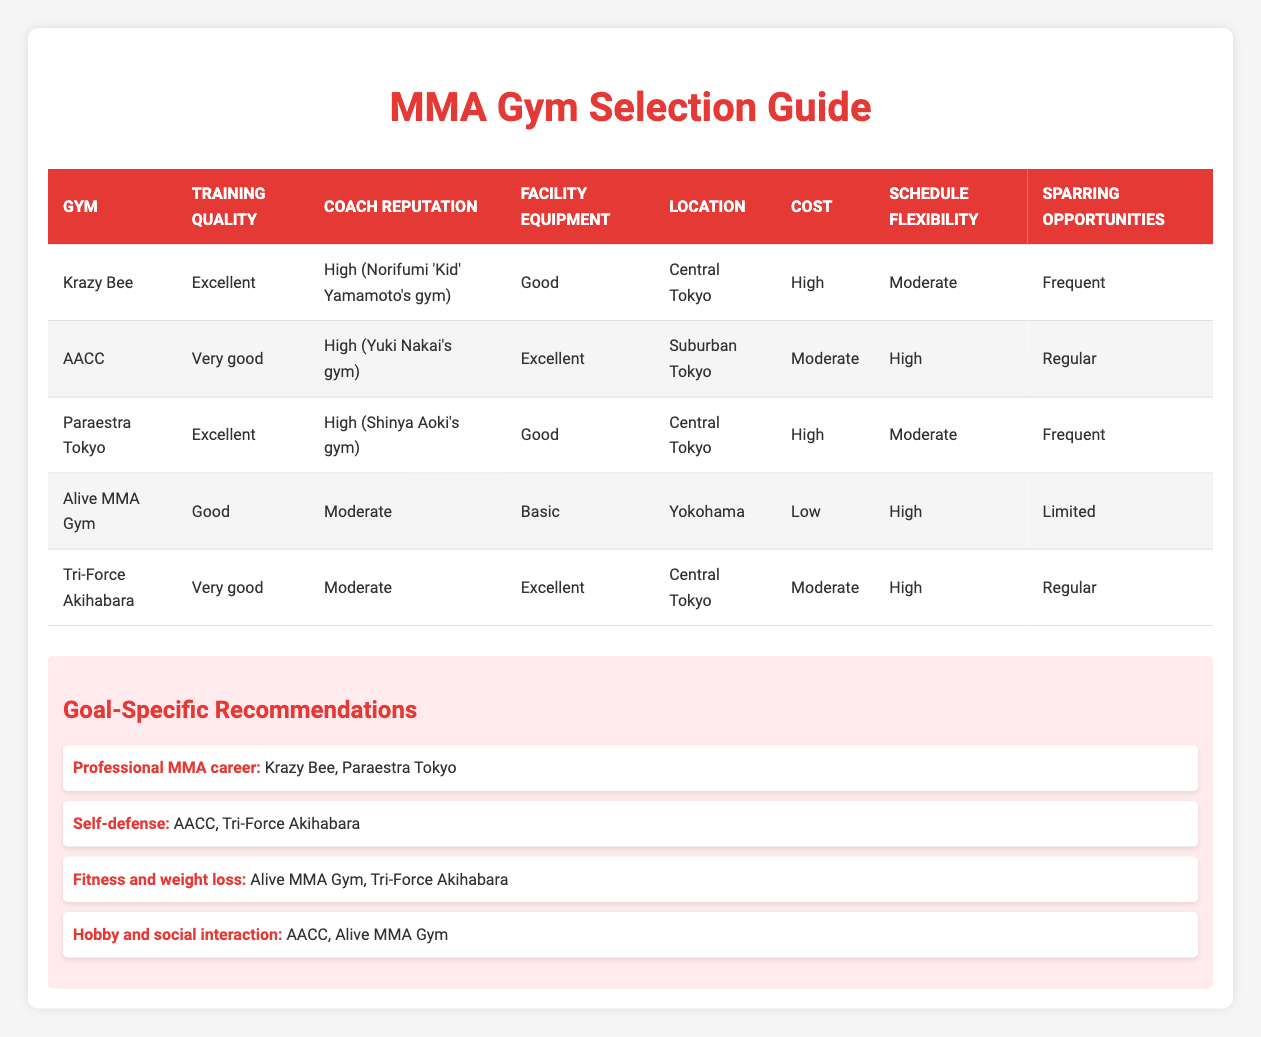What is the membership cost of Tri-Force Akihabara? Tri-Force Akihabara's membership cost is listed in the table as "Moderate."
Answer: Moderate Which gym has the highest coach reputation? Both Krazy Bee and AACC have a "High" coach reputation.
Answer: Krazy Bee and AACC Is the facility equipment at Alive MMA Gym better than that at Krazy Bee? Alive MMA Gym has "Basic" facility equipment, while Krazy Bee has "Good" equipment. Since "Good" is better than "Basic," the statement is false.
Answer: No What gym offers frequent sparring opportunities and has excellent training quality? According to the table, Krazy Bee and Paraestra Tokyo both have "Excellent" training quality, and both also have "Frequent" sparring opportunities. Therefore, the gyms that match both criteria are Krazy Bee and Paraestra Tokyo.
Answer: Krazy Bee and Paraestra Tokyo What is the average membership cost of the gyms listed? The costs listed are High, Moderate, High, Low, and Moderate. Assigning numerical values, we can estimate: High = 3, Moderate = 2, Low = 1. The average will be (3 + 2 + 3 + 1 + 2) / 5 = 2.2, rounding gives an average membership cost category close to Moderate.
Answer: Moderate Which gym is the best choice for someone looking for fitness and weight loss? The recommendation for fitness and weight loss indicates Alive MMA Gym and Tri-Force Akihabara. They were specifically noted for this goal according to the goal-specific recommendations.
Answer: Alive MMA Gym and Tri-Force Akihabara Is Paraestra Tokyo located in Central Tokyo? The table indicates that Paraestra Tokyo's location convenience is "Central Tokyo," which confirms the statement is true.
Answer: Yes Which gym has the best training quality but is considered to have a high membership cost? Both Krazy Bee and Paraestra Tokyo have "Excellent" training quality; however, they both also have a "High" membership cost, making them the best choices meeting both criteria.
Answer: Krazy Bee and Paraestra Tokyo 